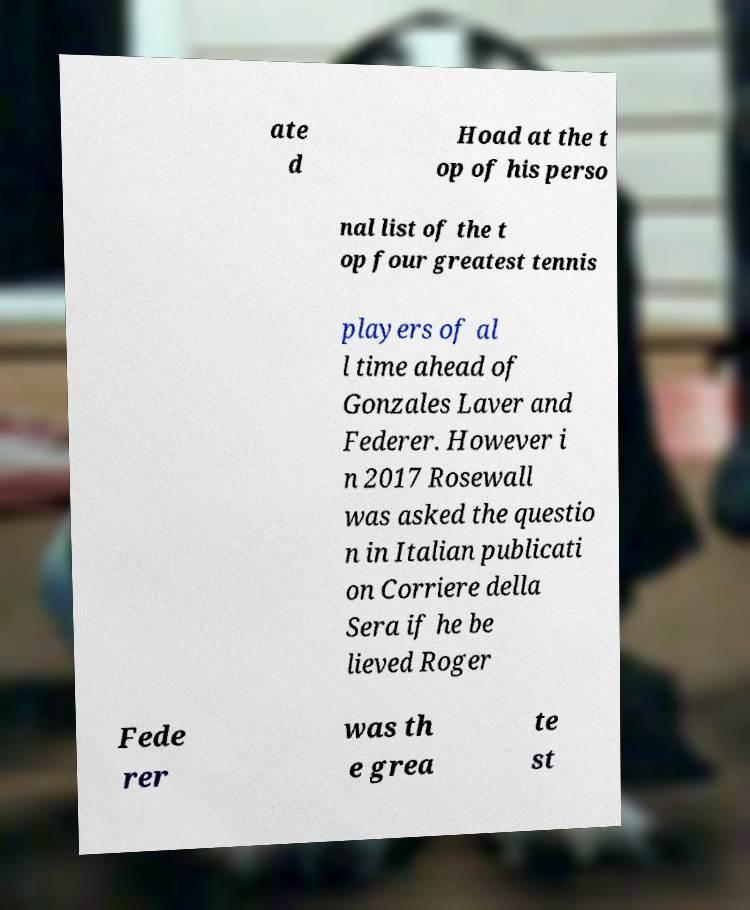Can you read and provide the text displayed in the image?This photo seems to have some interesting text. Can you extract and type it out for me? ate d Hoad at the t op of his perso nal list of the t op four greatest tennis players of al l time ahead of Gonzales Laver and Federer. However i n 2017 Rosewall was asked the questio n in Italian publicati on Corriere della Sera if he be lieved Roger Fede rer was th e grea te st 